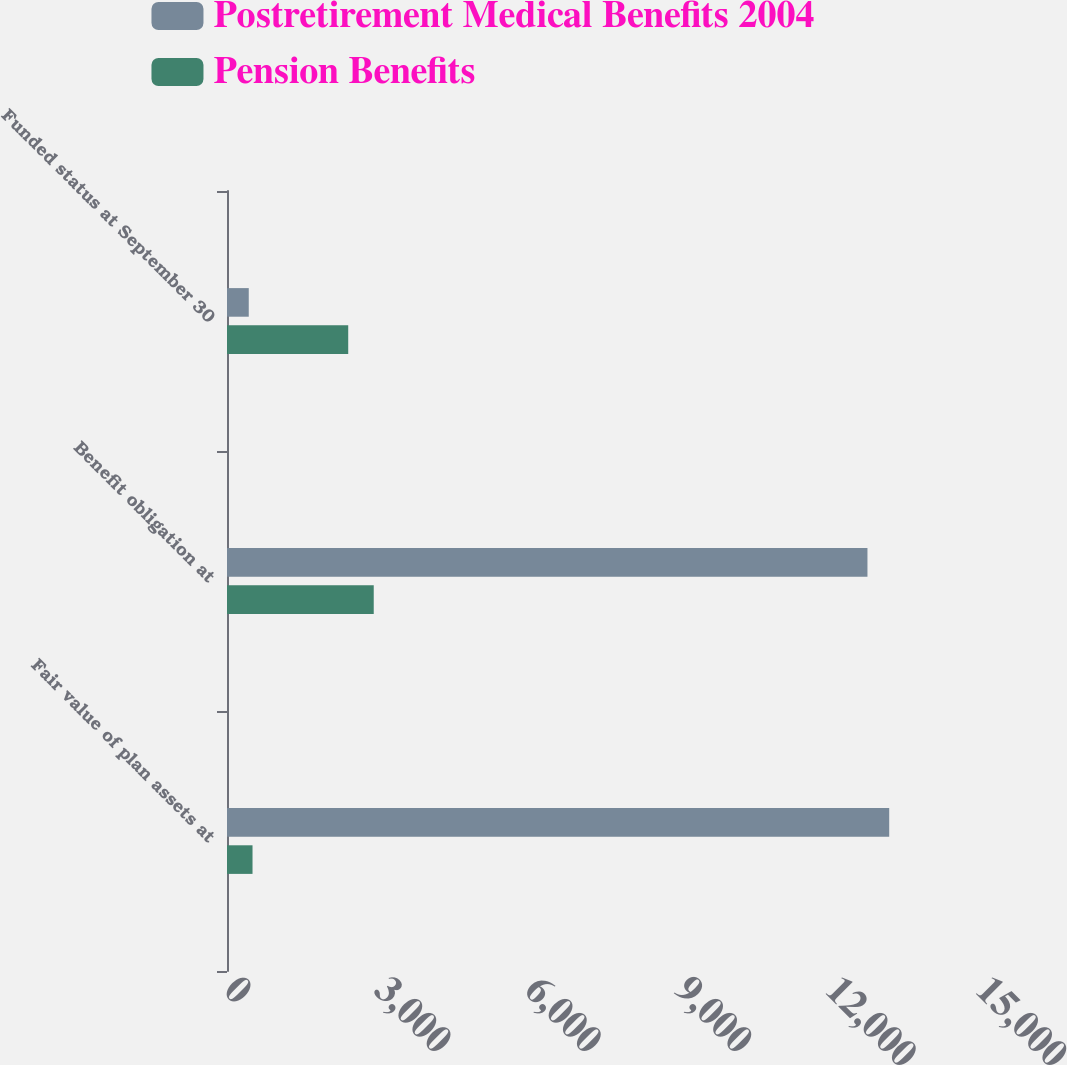Convert chart. <chart><loc_0><loc_0><loc_500><loc_500><stacked_bar_chart><ecel><fcel>Fair value of plan assets at<fcel>Benefit obligation at<fcel>Funded status at September 30<nl><fcel>Postretirement Medical Benefits 2004<fcel>13209<fcel>12775<fcel>434<nl><fcel>Pension Benefits<fcel>509<fcel>2927<fcel>2418<nl></chart> 